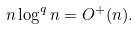Convert formula to latex. <formula><loc_0><loc_0><loc_500><loc_500>n \log ^ { q } n = O ^ { + } ( n ) .</formula> 